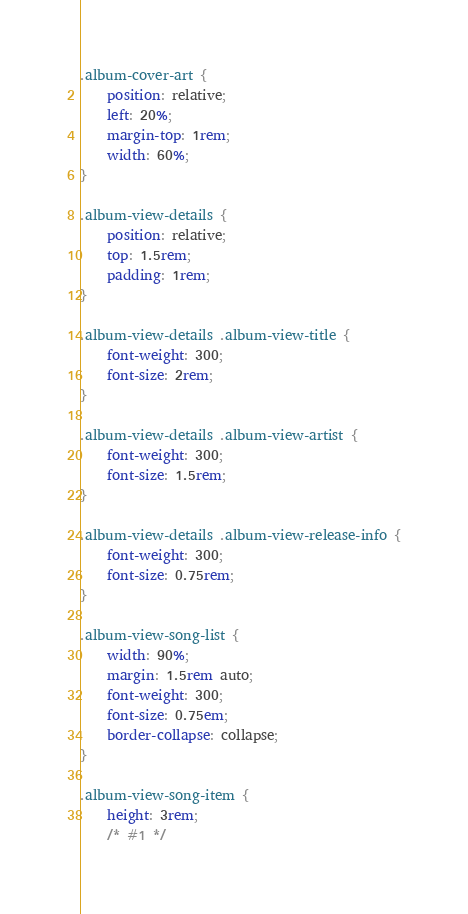Convert code to text. <code><loc_0><loc_0><loc_500><loc_500><_CSS_>
.album-cover-art {
    position: relative;
    left: 20%;
    margin-top: 1rem;
    width: 60%;
}

.album-view-details {
    position: relative;
    top: 1.5rem;
    padding: 1rem;
}

.album-view-details .album-view-title {
    font-weight: 300;
    font-size: 2rem;
}

.album-view-details .album-view-artist {
    font-weight: 300;
    font-size: 1.5rem;
}

.album-view-details .album-view-release-info {
    font-weight: 300;
    font-size: 0.75rem;
}

.album-view-song-list {
    width: 90%;
    margin: 1.5rem auto;
    font-weight: 300;
    font-size: 0.75em;
    border-collapse: collapse;
}

.album-view-song-item {
    height: 3rem;
    /* #1 */</code> 